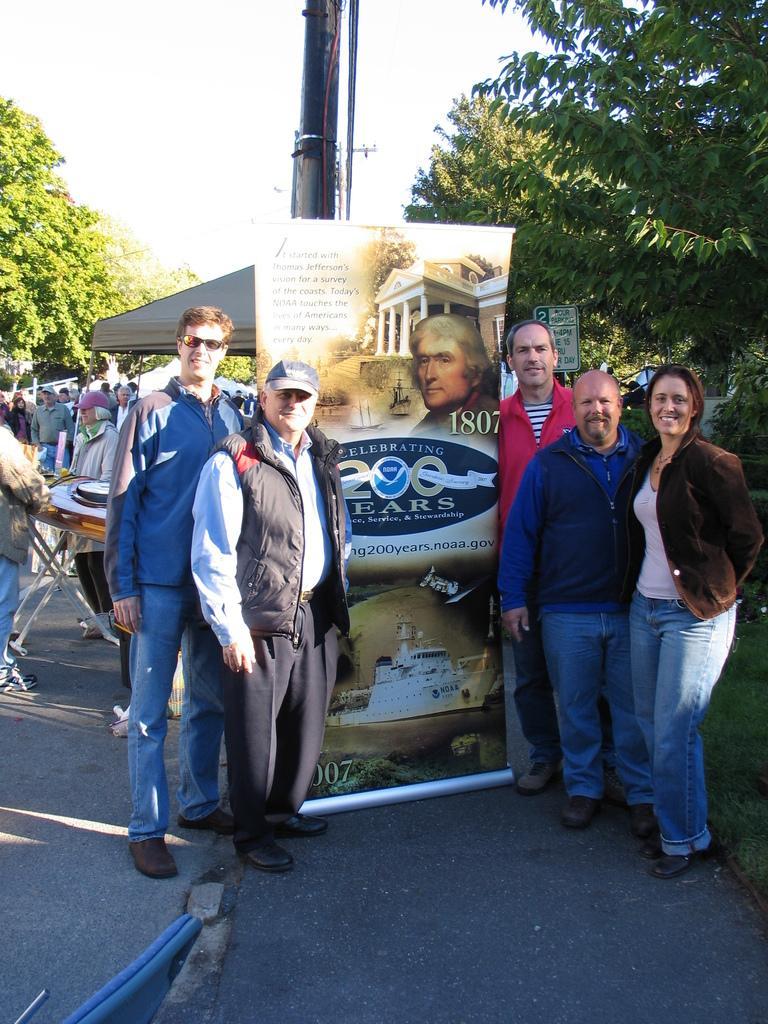In one or two sentences, can you explain what this image depicts? There are people standing and we can see banner and pipes on the surface,behind this banner we can see pole. In the background we can see people,objects on the table,board,tent,trees and sky. 